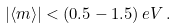Convert formula to latex. <formula><loc_0><loc_0><loc_500><loc_500>| \langle { m } \rangle | < ( 0 . 5 - 1 . 5 ) \, e V \, .</formula> 